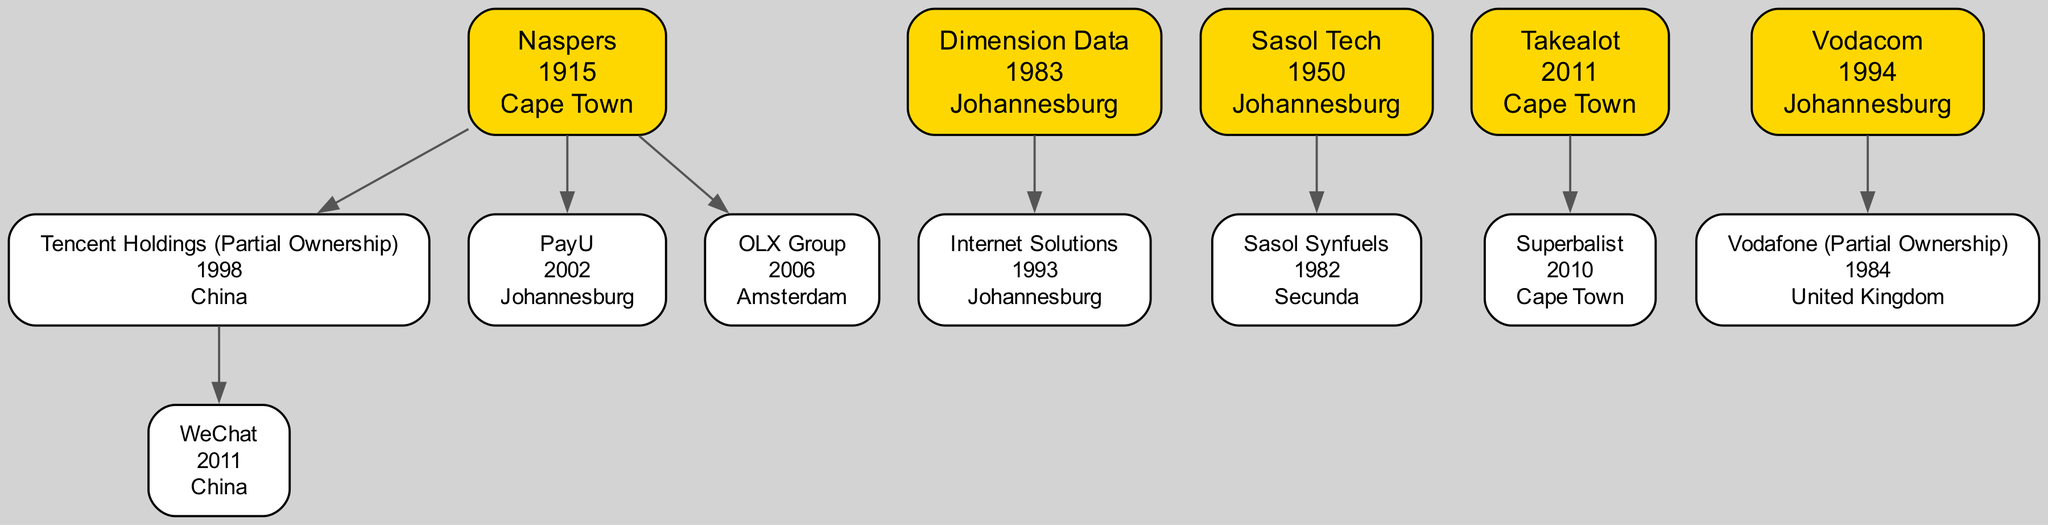What is the founding year of Naspers? According to the diagram, Naspers is listed with its founding year right next to its name, indicated as "1915."
Answer: 1915 Which company has a partial ownership with Vodacom? The diagram shows that the company Vodafone is connected to Vodacom with a note that indicates "Partial Ownership." This relationship provides the direct answer.
Answer: Vodafone How many companies are listed under Naspers? The diagram displays Naspers with several child nodes connected to it, specifically three companies: Tencent Holdings, PayU, and OLX Group. Counting these child nodes gives the total of three, which is the answer.
Answer: 3 What is the location of Sasol Tech? The diagram presents Sasol Tech with the location specified as "Johannesburg." This information is clearly indicated alongside the company name.
Answer: Johannesburg Which company is a child of Dimension Data? The diagram shows that Internet Solutions is directly connected under Dimension Data as its child node. This relationship allows us to identify the answer easily.
Answer: Internet Solutions How many total companies are shown in the diagram? The diagram lists a total of nine nodes, including all parent companies and their child companies. By counting each distinct node in the diagram, we can determine the answer.
Answer: 9 What is the founding year of the earliest company listed? By examining the founding years of all companies in the diagram, Sasol Tech, founded in "1950," is the earliest established company compared to others like Naspers (1915), Dimension Data (1983), etc. This makes the year the answer.
Answer: 1950 Which city has the most companies listed? By analyzing the locations shown in the diagram, Johannesburg has four companies noted (Dimension Data, Internet Solutions, Vodacom, and Sasol Tech). Analyzing all provided locations leads to identifying Johannesburg as the answer.
Answer: Johannesburg Name a company that was founded after 2000. In the diagram, PayU is noted with a founding year of "2002," and Takealot is noted with "2011," both of which are after the year 2000. Either of these companies can serve as an answer.
Answer: Takealot 